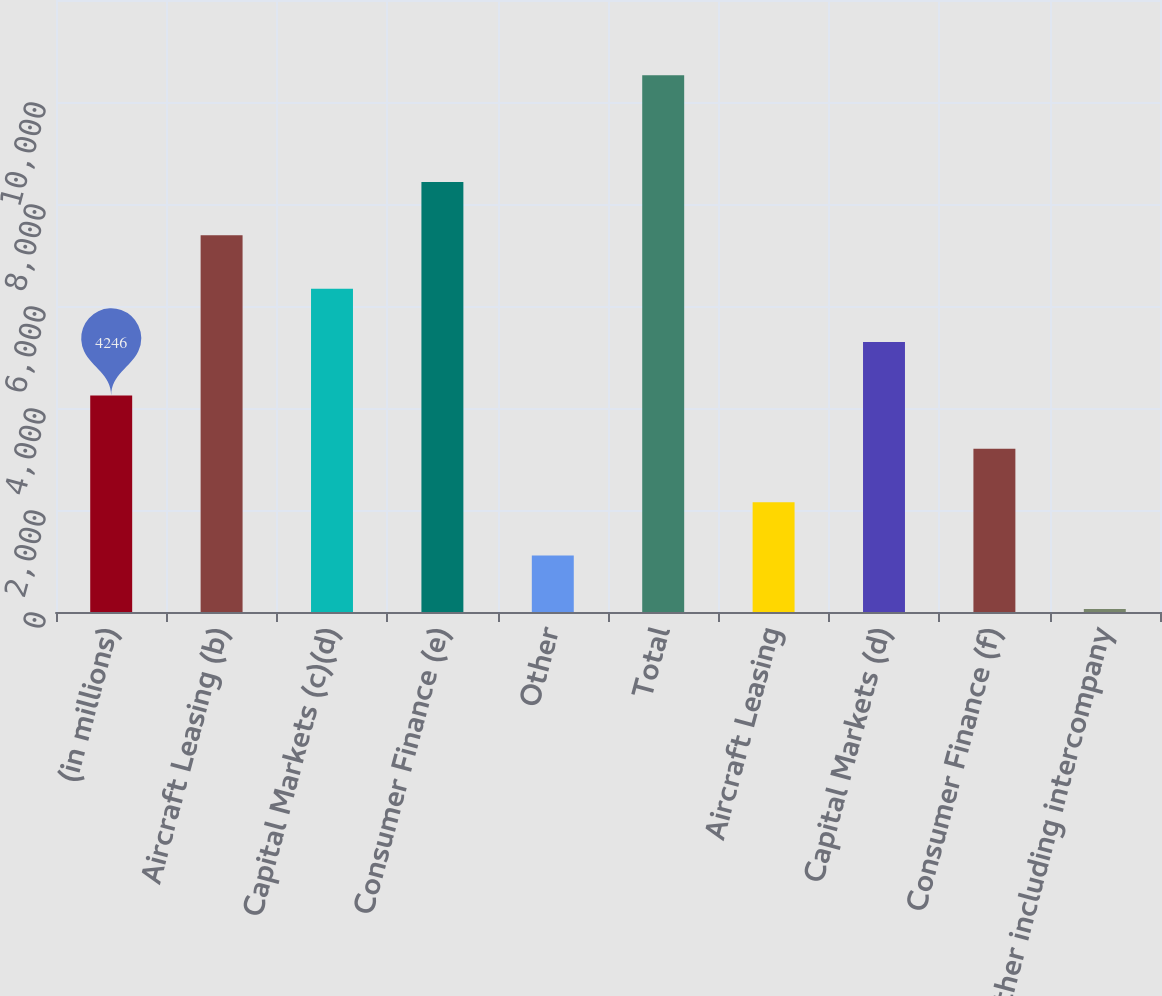Convert chart. <chart><loc_0><loc_0><loc_500><loc_500><bar_chart><fcel>(in millions)<fcel>Aircraft Leasing (b)<fcel>Capital Markets (c)(d)<fcel>Consumer Finance (e)<fcel>Other<fcel>Total<fcel>Aircraft Leasing<fcel>Capital Markets (d)<fcel>Consumer Finance (f)<fcel>Other including intercompany<nl><fcel>4246<fcel>7385.5<fcel>6339<fcel>8432<fcel>1106.5<fcel>10525<fcel>2153<fcel>5292.5<fcel>3199.5<fcel>60<nl></chart> 